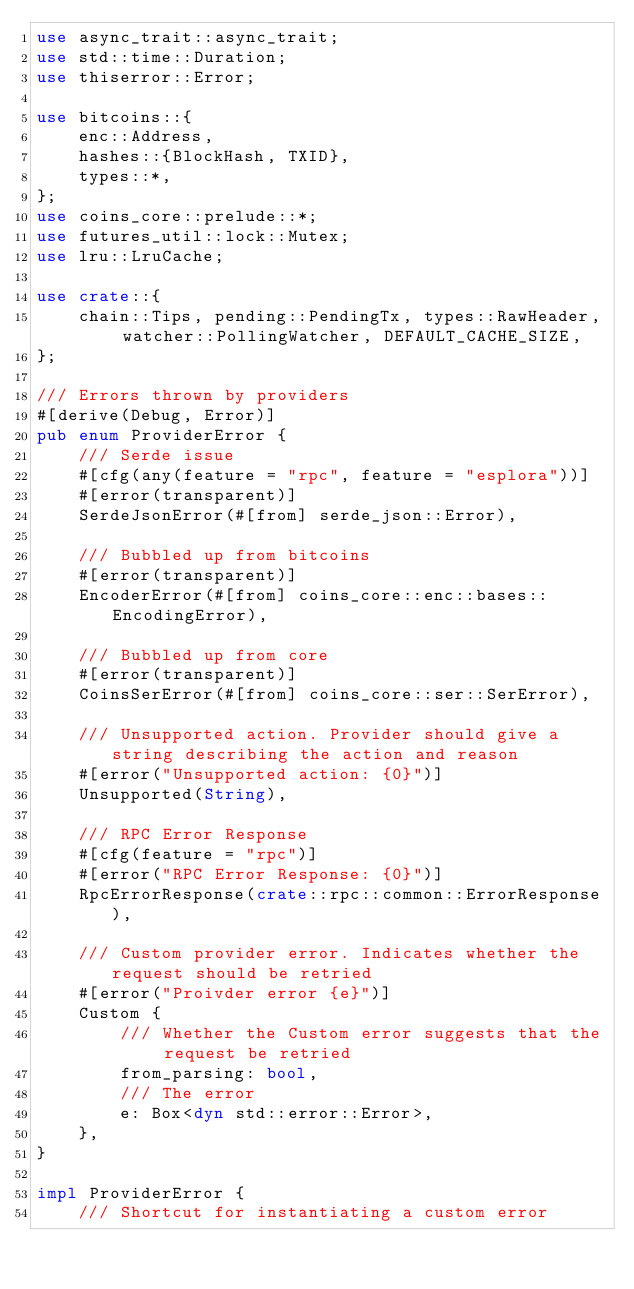<code> <loc_0><loc_0><loc_500><loc_500><_Rust_>use async_trait::async_trait;
use std::time::Duration;
use thiserror::Error;

use bitcoins::{
    enc::Address,
    hashes::{BlockHash, TXID},
    types::*,
};
use coins_core::prelude::*;
use futures_util::lock::Mutex;
use lru::LruCache;

use crate::{
    chain::Tips, pending::PendingTx, types::RawHeader, watcher::PollingWatcher, DEFAULT_CACHE_SIZE,
};

/// Errors thrown by providers
#[derive(Debug, Error)]
pub enum ProviderError {
    /// Serde issue
    #[cfg(any(feature = "rpc", feature = "esplora"))]
    #[error(transparent)]
    SerdeJsonError(#[from] serde_json::Error),

    /// Bubbled up from bitcoins
    #[error(transparent)]
    EncoderError(#[from] coins_core::enc::bases::EncodingError),

    /// Bubbled up from core
    #[error(transparent)]
    CoinsSerError(#[from] coins_core::ser::SerError),

    /// Unsupported action. Provider should give a string describing the action and reason
    #[error("Unsupported action: {0}")]
    Unsupported(String),

    /// RPC Error Response
    #[cfg(feature = "rpc")]
    #[error("RPC Error Response: {0}")]
    RpcErrorResponse(crate::rpc::common::ErrorResponse),

    /// Custom provider error. Indicates whether the request should be retried
    #[error("Proivder error {e}")]
    Custom {
        /// Whether the Custom error suggests that the request be retried
        from_parsing: bool,
        /// The error
        e: Box<dyn std::error::Error>,
    },
}

impl ProviderError {
    /// Shortcut for instantiating a custom error</code> 